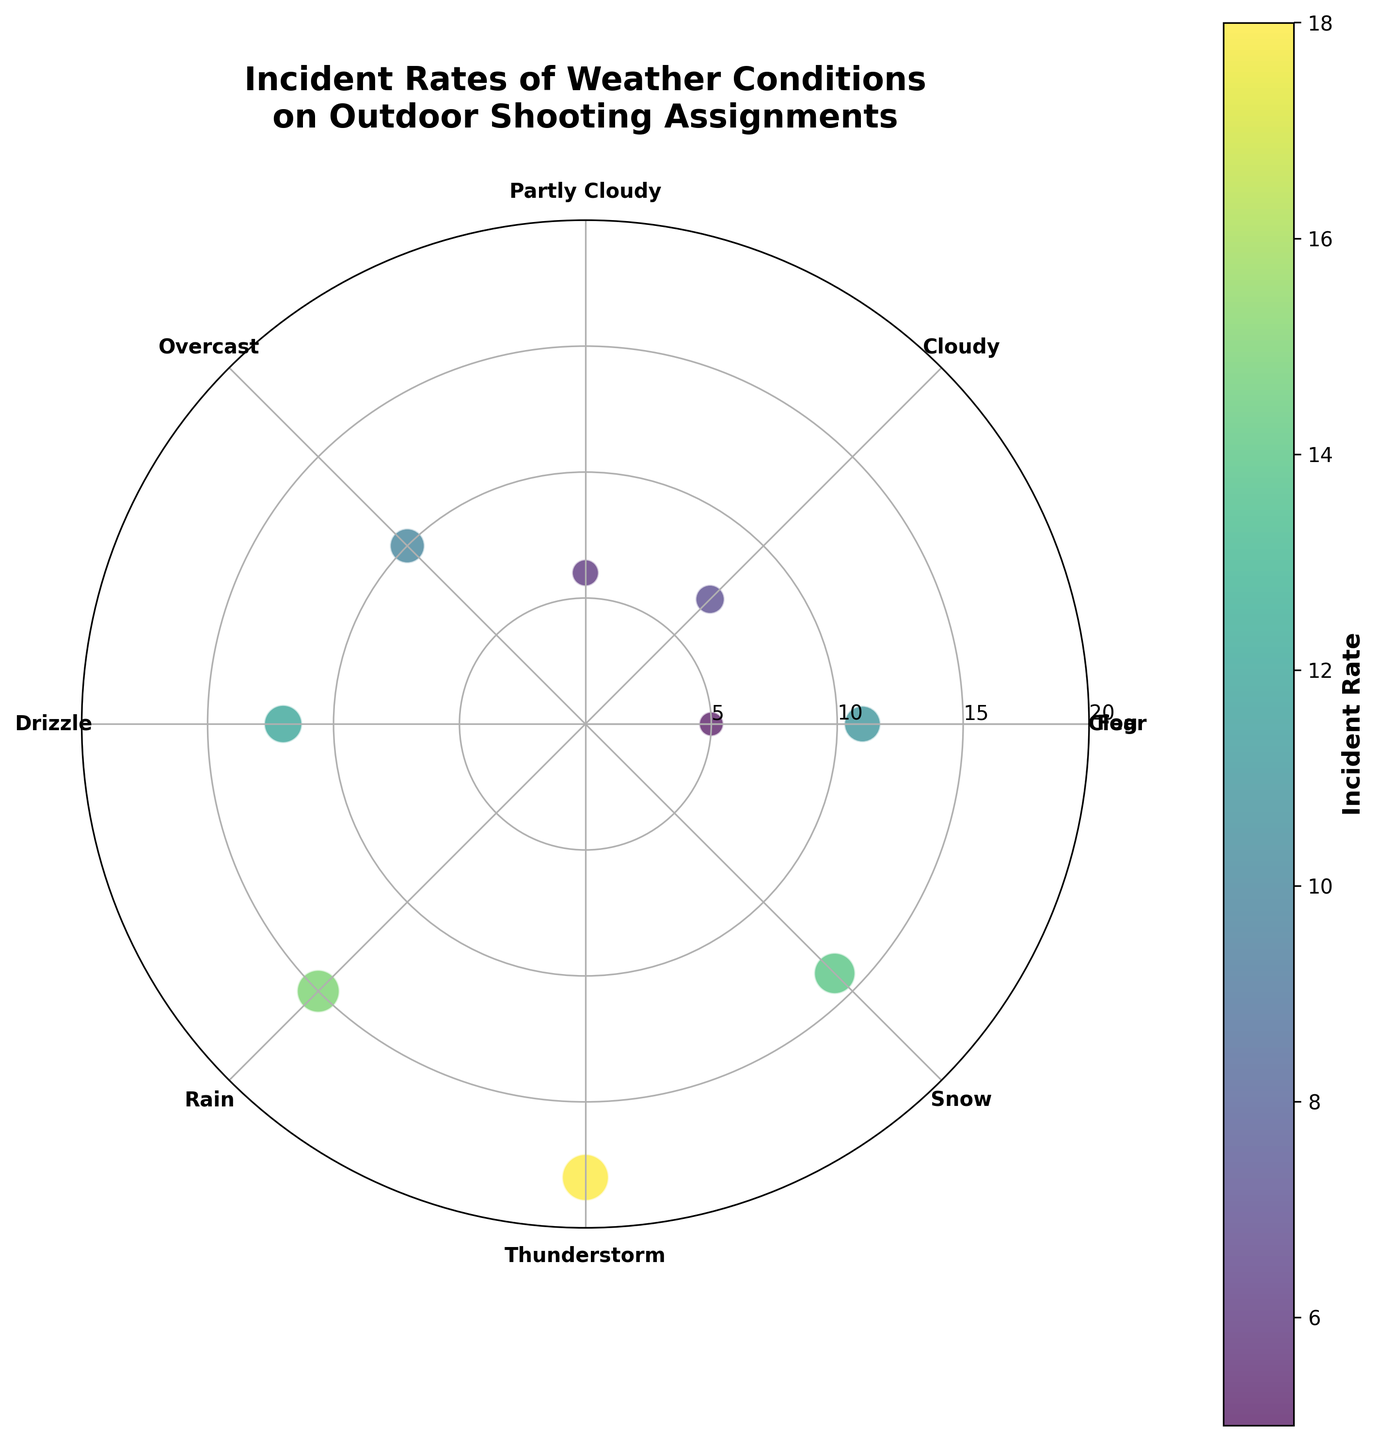Which weather condition has the highest incident rate? By looking at the color intensity and size of the points on the polar scatter chart, we can identify the highest incident rate. The point for Thunderstorm (at an angle of 270 degrees) is the largest and has the most intense color. This indicates it has the highest incident rate.
Answer: Thunderstorm Which weather conditions have incident rates greater than 10? Inspecting the values associated with each data point on the polar scatter chart, the conditions with incident rates greater than 10 are Drizzle (12), Rain (15), Thunderstorm (18), Snow (14), and Fog (11).
Answer: Drizzle, Rain, Thunderstorm, Snow, Fog What is the angle associated with the 'Overcast' weather condition, and what does its incident rate look like? The 'Overcast' label on the radar chart is placed at 135 degrees. By observing its corresponding point, the incident rate displayed is 10.
Answer: 135 degrees, 10 How many weather conditions have incident rates less than 10? By examining the polar scatter chart, we identify data points at Clear (5), Cloudy (7), and Partly Cloudy (6), which are all less than 10. Therefore, there are three weather conditions with incident rates less than 10.
Answer: Three Which weather type has a rate closest to 10, and where is it located on the chart? Observing the scatter chart, Overcast (at an angle of 135 degrees) is the weather type with an incident rate of 10, which is exactly 10.
Answer: Overcast, at 135 degrees What is the average incident rate of Clear and Snow weather conditions? The incident rates for Clear and Snow are 5 and 14, respectively. The sum is 5 + 14 = 19, and the average is 19 / 2 = 9.5.
Answer: 9.5 Compare the incident rates of Cloudy and Partly Cloudy weather conditions. Which one is higher? By looking at their incident rates, Cloudy is 7, and Partly Cloudy is 6. Therefore, Cloudy has a higher incident rate.
Answer: Cloudy What is the total incident rate for Drizzle, Rain, and Thunderstorm? Adding the incident rates for Drizzle (12), Rain (15), and Thunderstorm (18), we get 12 + 15 + 18 = 45.
Answer: 45 Identify the weather condition with an incident rate of 14 and specify its angle. On the polar scatter chart, Snow has an incident rate of 14, and its angle is 315 degrees.
Answer: Snow, 315 degrees Which weather conditions are exactly at 0 degrees and 360 degrees, and what are their incident rates? The conditions at 0 degrees and 360 degrees are Clear and Fog, respectively. They have incident rates of 5 and 11.
Answer: Clear (5), Fog (11) 